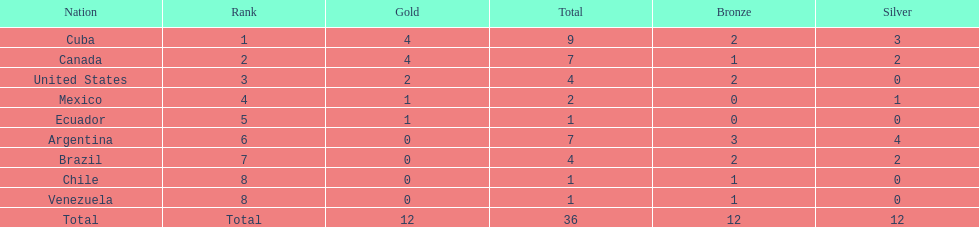What is the total number of nations that did not win gold? 4. 